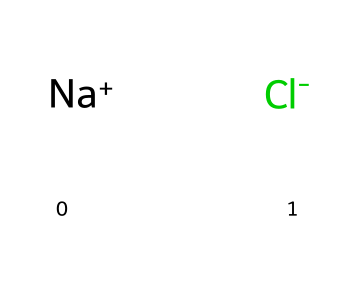how many atoms are in sodium chloride? The chemical structure of sodium chloride consists of one sodium ion (Na+) and one chloride ion (Cl-), which totals two atoms.
Answer: 2 what type of compound is sodium chloride? Sodium chloride is classified as an ionic compound because it is formed by the electrostatic attraction between the positively charged sodium ions and the negatively charged chloride ions.
Answer: ionic compound what is the charge of the sodium ion? The sodium ion in the structure is indicated by Na+ which shows it has a positive charge.
Answer: positive what is the charge of the chloride ion? The chloride ion is represented by Cl- in the structure, indicating it has a negative charge.
Answer: negative what role do electrolytes like sodium chloride play in sports drinks? Electrolytes, including sodium chloride, help maintain fluid balance in the body, enhance muscle function, and restore lost electrolytes during physical activity.
Answer: maintain fluid balance how do sodium and chloride interact in the solution? In a solution, sodium ions and chloride ions dissociate and interact through ionic bonds, leading to electrostatic attraction in the liquid, which helps to maintain the electrolyte balance in beverages.
Answer: dissociate and attract why is sodium chloride important for athletes? Sodium chloride is crucial for athletes as it helps to prevent dehydration, muscle cramps, and replenish sodium lost through sweat during intense physical activity.
Answer: prevent dehydration 